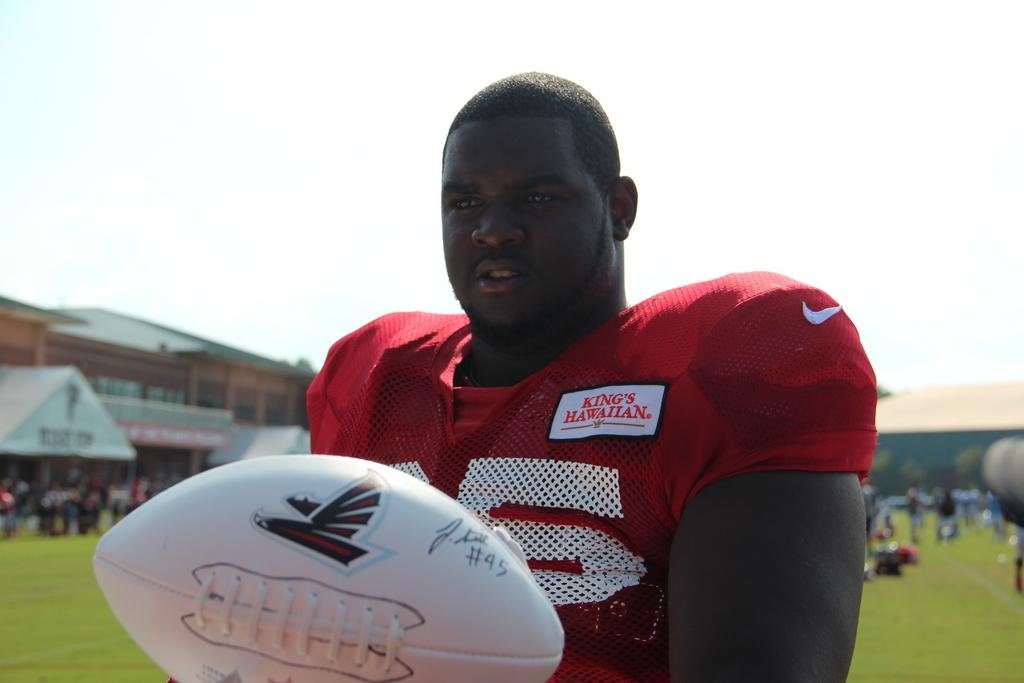Where was the image taken? The image was taken at a stadium. What is the man in the center of the image wearing? The man is wearing a red jersey. What is the man holding in the image? The man is holding a ball. What can be seen in the background of the image? There is grass, a building, and the sky visible in the background of the image. Can you describe the crowd in the background of the image? There is a crowd in the background of the image. What type of apple can be seen growing on the brick wall in the image? There is no apple or brick wall present in the image. How many bricks are visible in the image? There are no bricks visible in the image. 